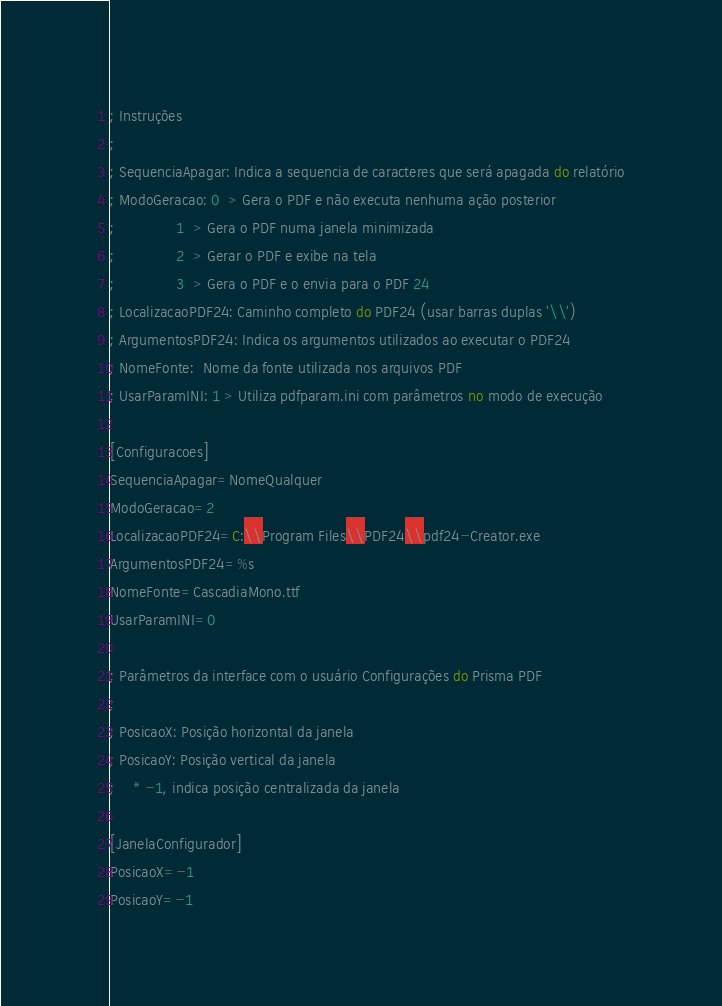Convert code to text. <code><loc_0><loc_0><loc_500><loc_500><_SQL_>; Instruções
;
; SequenciaApagar: Indica a sequencia de caracteres que será apagada do relatório
; ModoGeracao: 0  > Gera o PDF e não executa nenhuma ação posterior
;              1  > Gera o PDF numa janela minimizada
;              2  > Gerar o PDF e exibe na tela
;              3  > Gera o PDF e o envia para o PDF 24
; LocalizacaoPDF24: Caminho completo do PDF24 (usar barras duplas '\\')
; ArgumentosPDF24: Indica os argumentos utilizados ao executar o PDF24
; NomeFonte:  Nome da fonte utilizada nos arquivos PDF
; UsarParamINI: 1 > Utiliza pdfparam.ini com parâmetros no modo de execução

[Configuracoes]
SequenciaApagar=NomeQualquer
ModoGeracao=2
LocalizacaoPDF24=C:\\Program Files\\PDF24\\pdf24-Creator.exe
ArgumentosPDF24=%s
NomeFonte=CascadiaMono.ttf
UsarParamINI=0

; Parâmetros da interface com o usuário Configurações do Prisma PDF
; 
; PosicaoX: Posição horizontal da janela
; PosicaoY: Posição vertical da janela
;    * -1, indica posição centralizada da janela

[JanelaConfigurador]
PosicaoX=-1
PosicaoY=-1</code> 